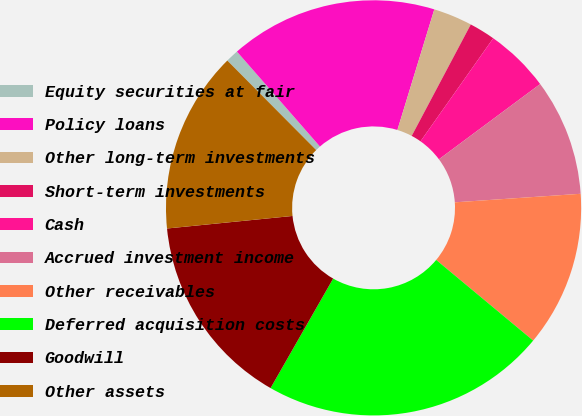Convert chart. <chart><loc_0><loc_0><loc_500><loc_500><pie_chart><fcel>Equity securities at fair<fcel>Policy loans<fcel>Other long-term investments<fcel>Short-term investments<fcel>Cash<fcel>Accrued investment income<fcel>Other receivables<fcel>Deferred acquisition costs<fcel>Goodwill<fcel>Other assets<nl><fcel>1.01%<fcel>16.16%<fcel>3.03%<fcel>2.02%<fcel>5.05%<fcel>9.09%<fcel>12.12%<fcel>22.22%<fcel>15.15%<fcel>14.14%<nl></chart> 